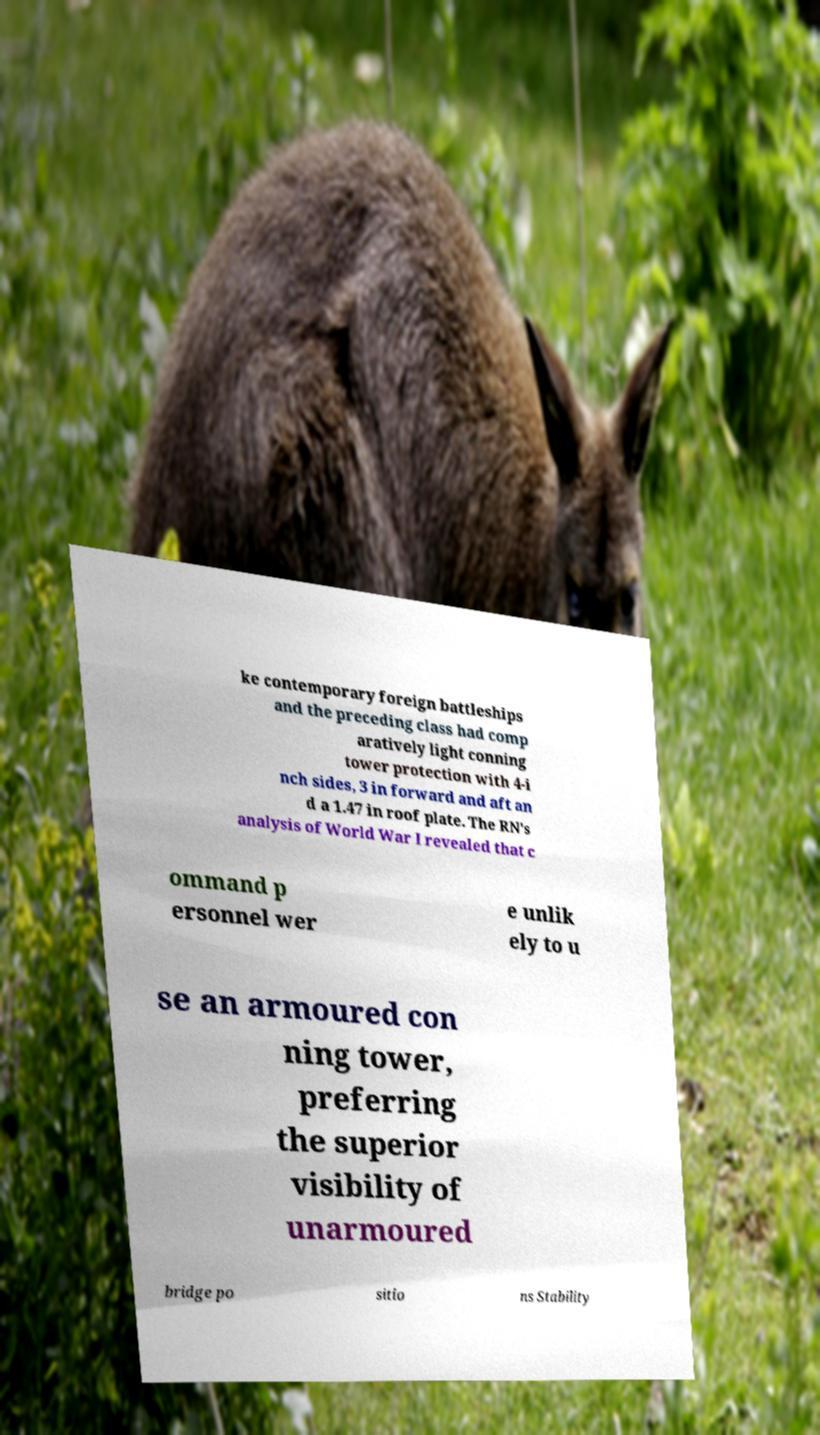There's text embedded in this image that I need extracted. Can you transcribe it verbatim? ke contemporary foreign battleships and the preceding class had comp aratively light conning tower protection with 4-i nch sides, 3 in forward and aft an d a 1.47 in roof plate. The RN's analysis of World War I revealed that c ommand p ersonnel wer e unlik ely to u se an armoured con ning tower, preferring the superior visibility of unarmoured bridge po sitio ns Stability 